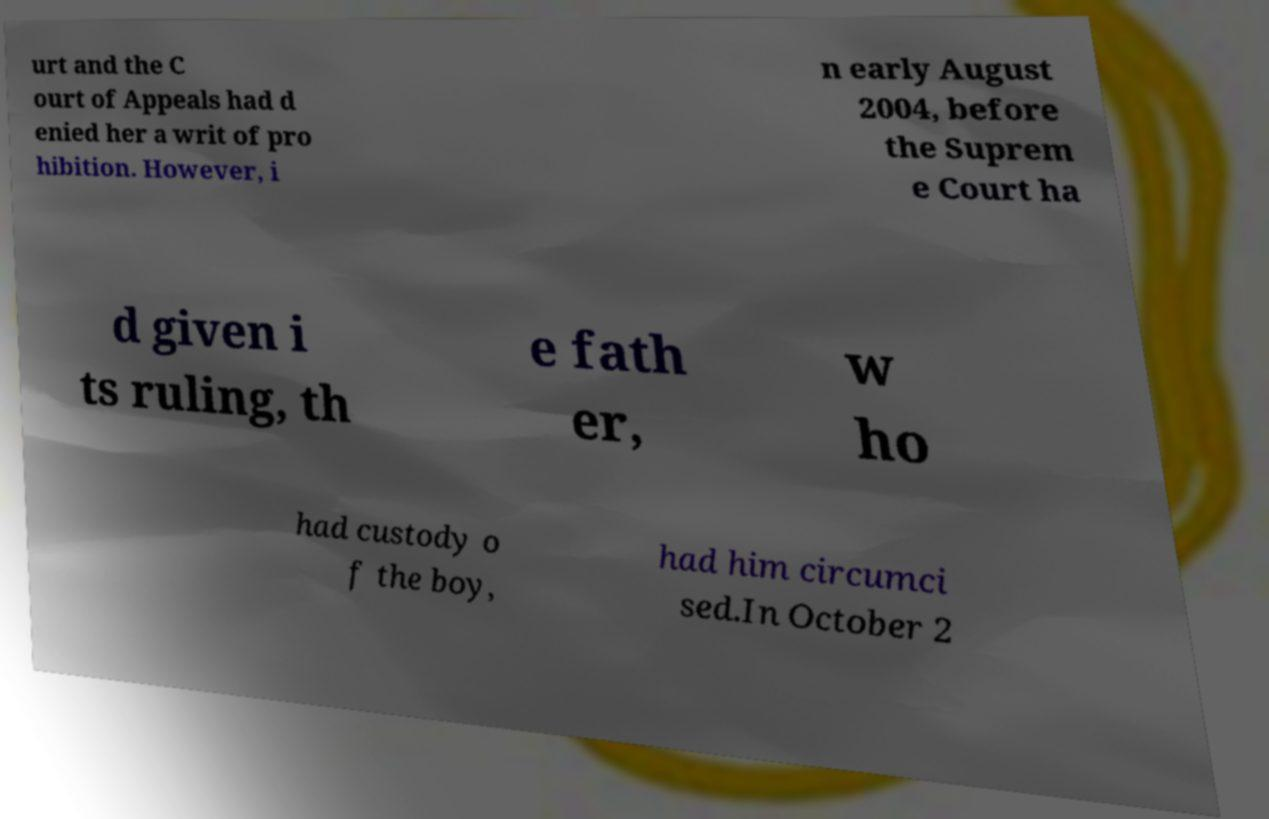Could you assist in decoding the text presented in this image and type it out clearly? urt and the C ourt of Appeals had d enied her a writ of pro hibition. However, i n early August 2004, before the Suprem e Court ha d given i ts ruling, th e fath er, w ho had custody o f the boy, had him circumci sed.In October 2 